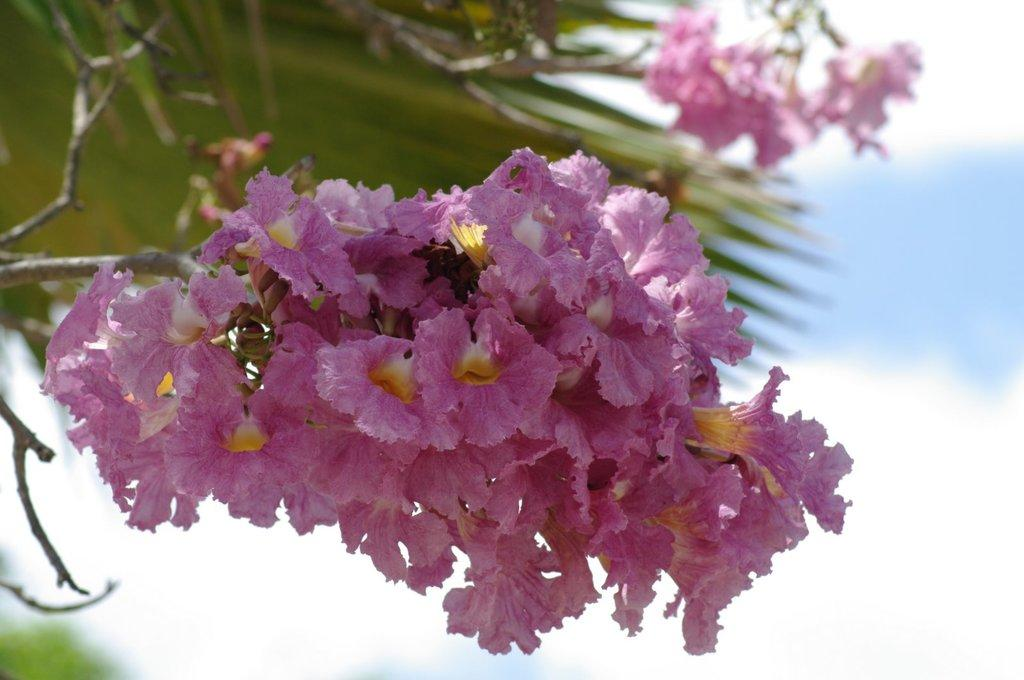What type of plants can be seen in the image? There are flowers and leaves in the image. Can you describe the appearance of the flowers? Unfortunately, the specific appearance of the flowers cannot be determined from the provided facts. What else is present in the image besides flowers and leaves? The provided facts do not mention any other objects or subjects in the image. Can you tell me how many horses are present in the image? There is no horse present in the image; it only features flowers and leaves. What type of ship can be seen sailing in the background of the image? There is no ship present in the image; it only features flowers and leaves. 